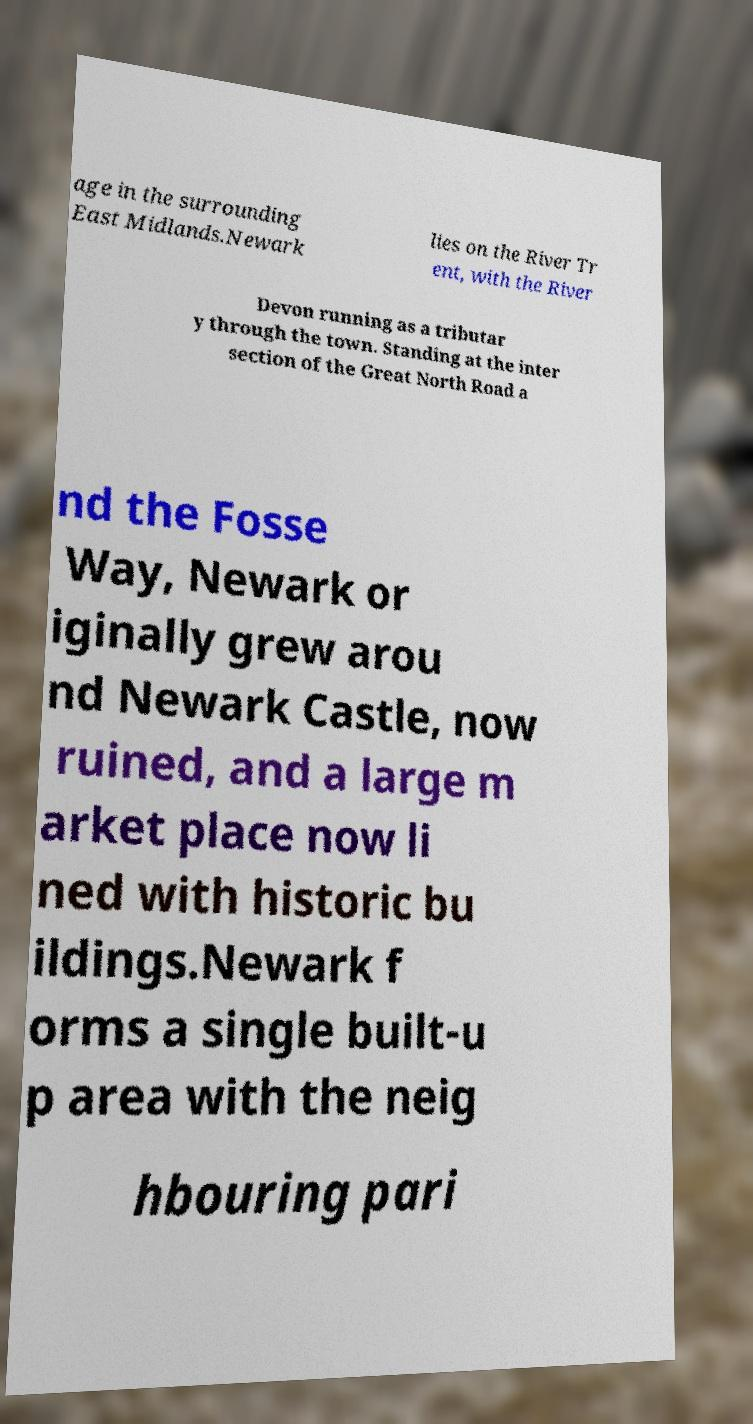Can you accurately transcribe the text from the provided image for me? age in the surrounding East Midlands.Newark lies on the River Tr ent, with the River Devon running as a tributar y through the town. Standing at the inter section of the Great North Road a nd the Fosse Way, Newark or iginally grew arou nd Newark Castle, now ruined, and a large m arket place now li ned with historic bu ildings.Newark f orms a single built-u p area with the neig hbouring pari 